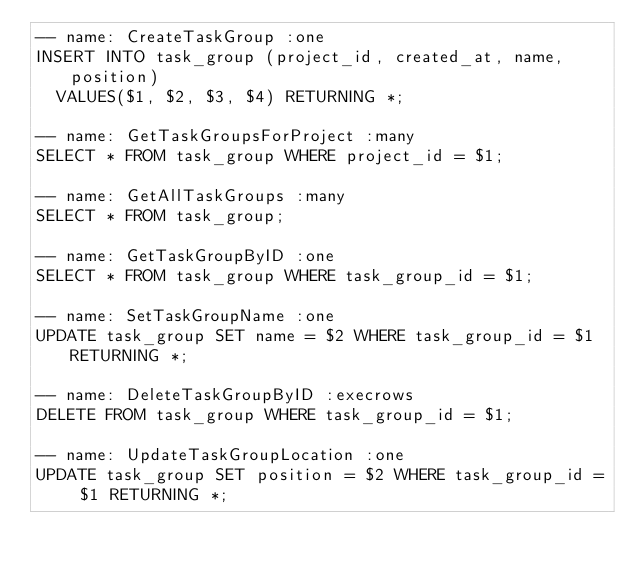<code> <loc_0><loc_0><loc_500><loc_500><_SQL_>-- name: CreateTaskGroup :one
INSERT INTO task_group (project_id, created_at, name, position)
  VALUES($1, $2, $3, $4) RETURNING *;

-- name: GetTaskGroupsForProject :many
SELECT * FROM task_group WHERE project_id = $1;

-- name: GetAllTaskGroups :many
SELECT * FROM task_group;

-- name: GetTaskGroupByID :one
SELECT * FROM task_group WHERE task_group_id = $1;

-- name: SetTaskGroupName :one
UPDATE task_group SET name = $2 WHERE task_group_id = $1 RETURNING *;

-- name: DeleteTaskGroupByID :execrows
DELETE FROM task_group WHERE task_group_id = $1;

-- name: UpdateTaskGroupLocation :one
UPDATE task_group SET position = $2 WHERE task_group_id = $1 RETURNING *;

</code> 